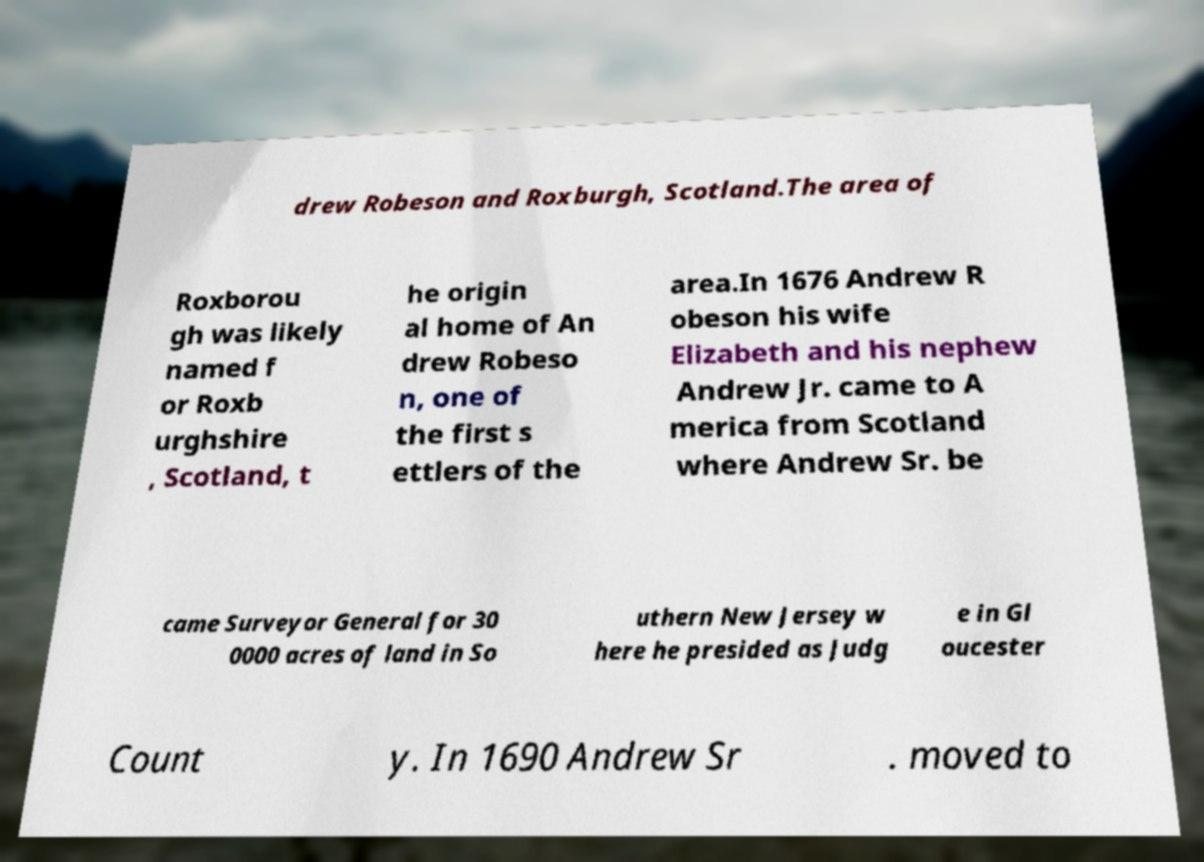Can you read and provide the text displayed in the image?This photo seems to have some interesting text. Can you extract and type it out for me? drew Robeson and Roxburgh, Scotland.The area of Roxborou gh was likely named f or Roxb urghshire , Scotland, t he origin al home of An drew Robeso n, one of the first s ettlers of the area.In 1676 Andrew R obeson his wife Elizabeth and his nephew Andrew Jr. came to A merica from Scotland where Andrew Sr. be came Surveyor General for 30 0000 acres of land in So uthern New Jersey w here he presided as Judg e in Gl oucester Count y. In 1690 Andrew Sr . moved to 